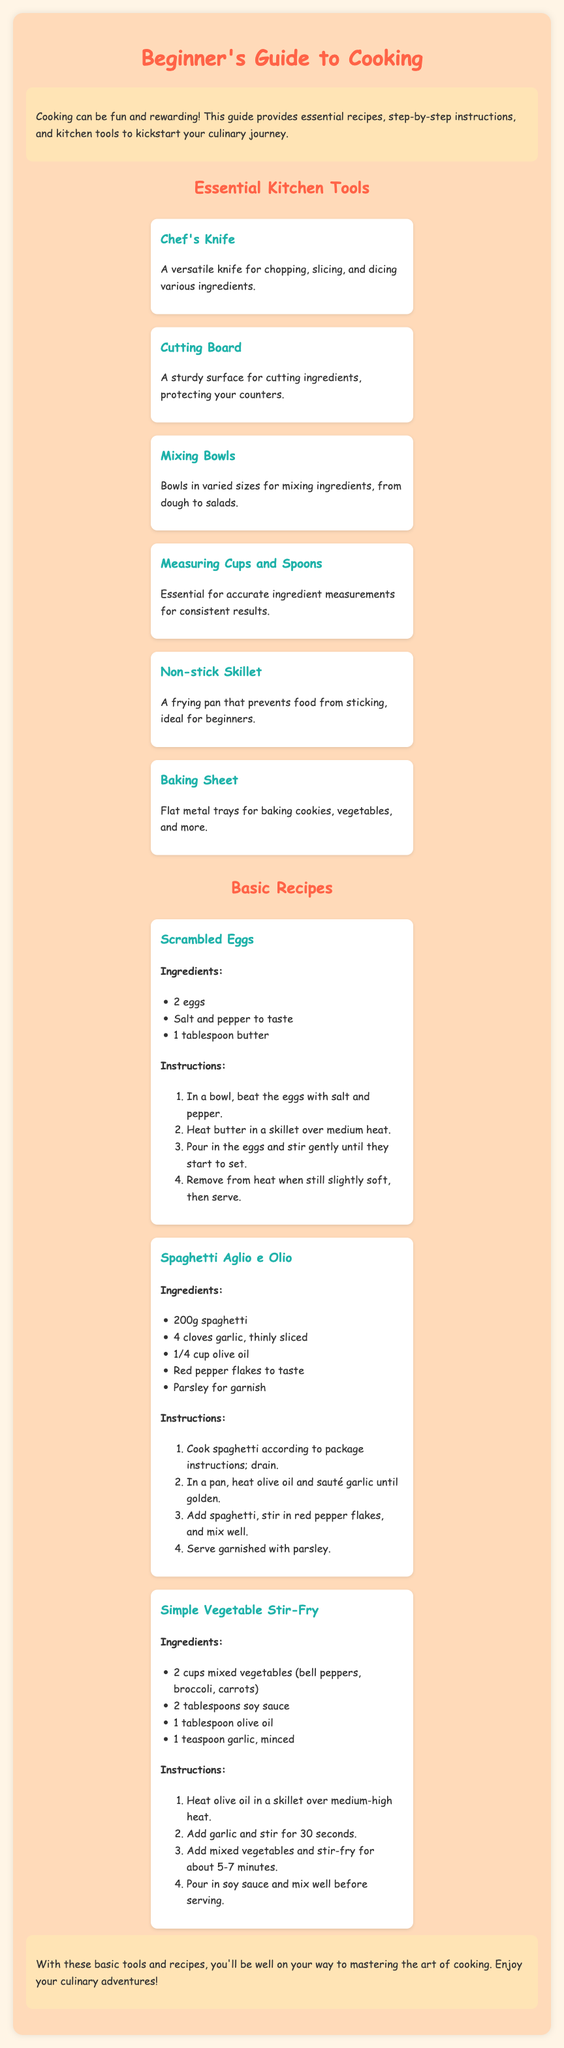What is the title of the document? The title is the main heading at the top of the document, which provides the overall theme or topic.
Answer: Beginner's Guide to Cooking How many essential kitchen tools are listed? The number of tools can be found by counting the items presented under the "Essential Kitchen Tools" section.
Answer: 6 What is the first recipe mentioned? The first recipe is the one that appears at the top of the "Basic Recipes" section, listing its name.
Answer: Scrambled Eggs What is the main ingredient for Spaghetti Aglio e Olio? The main ingredient is specified in the list of ingredients for that recipe.
Answer: Spaghetti What cooking technique is primarily used in the recipe for Simple Vegetable Stir-Fry? The technique is described in the instructions and is associated with how the vegetables are prepared.
Answer: Stir-fry Which kitchen tool is used for chopping, slicing, and dicing? The tool is identified in the description of essential kitchen tools, indicating its purpose.
Answer: Chef's Knife How many ingredients are needed for the Scrambled Eggs recipe? The number of ingredients can be counted from the list in the recipe section.
Answer: 3 What should you do after heating the olive oil for a stir-fry? The instruction following the heating provides the next step in the process.
Answer: Add garlic What color is the background of the document? The color can be seen in the overall layout design presented at the beginning of the document.
Answer: Light orange 